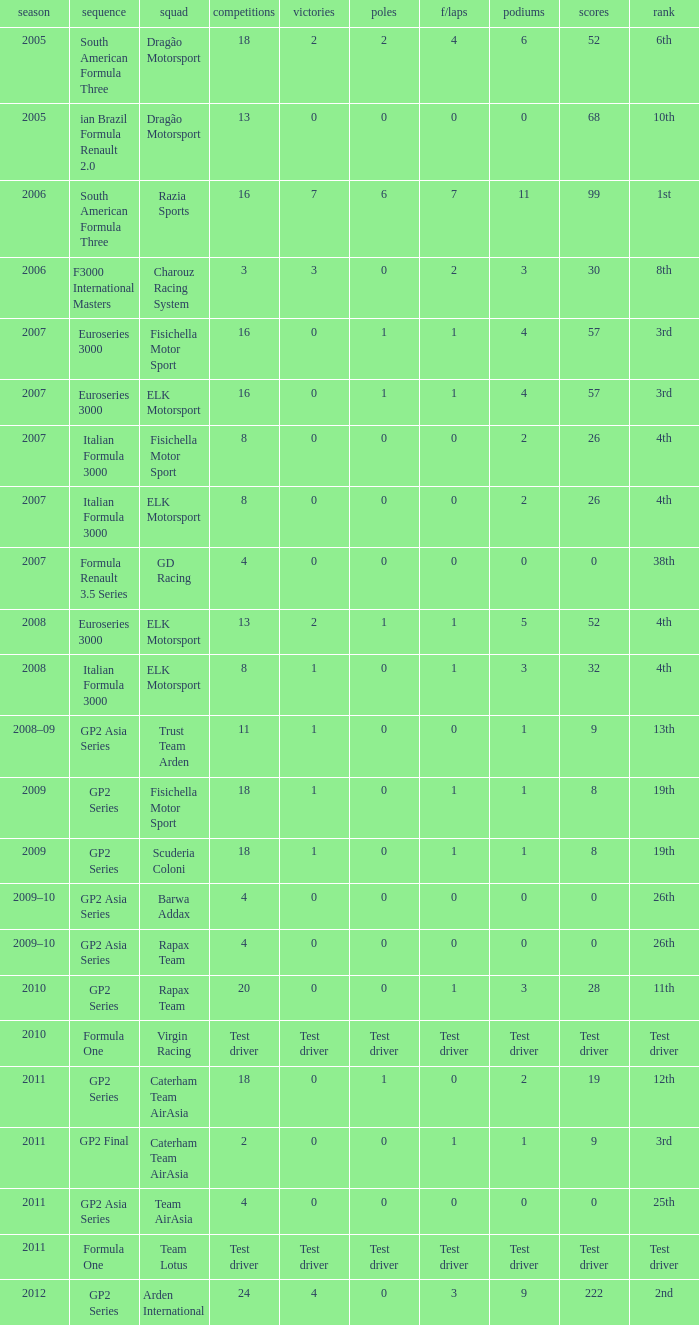What were the points in the year when his Wins were 0, his Podiums were 0, and he drove in 4 races? 0, 0, 0, 0. 